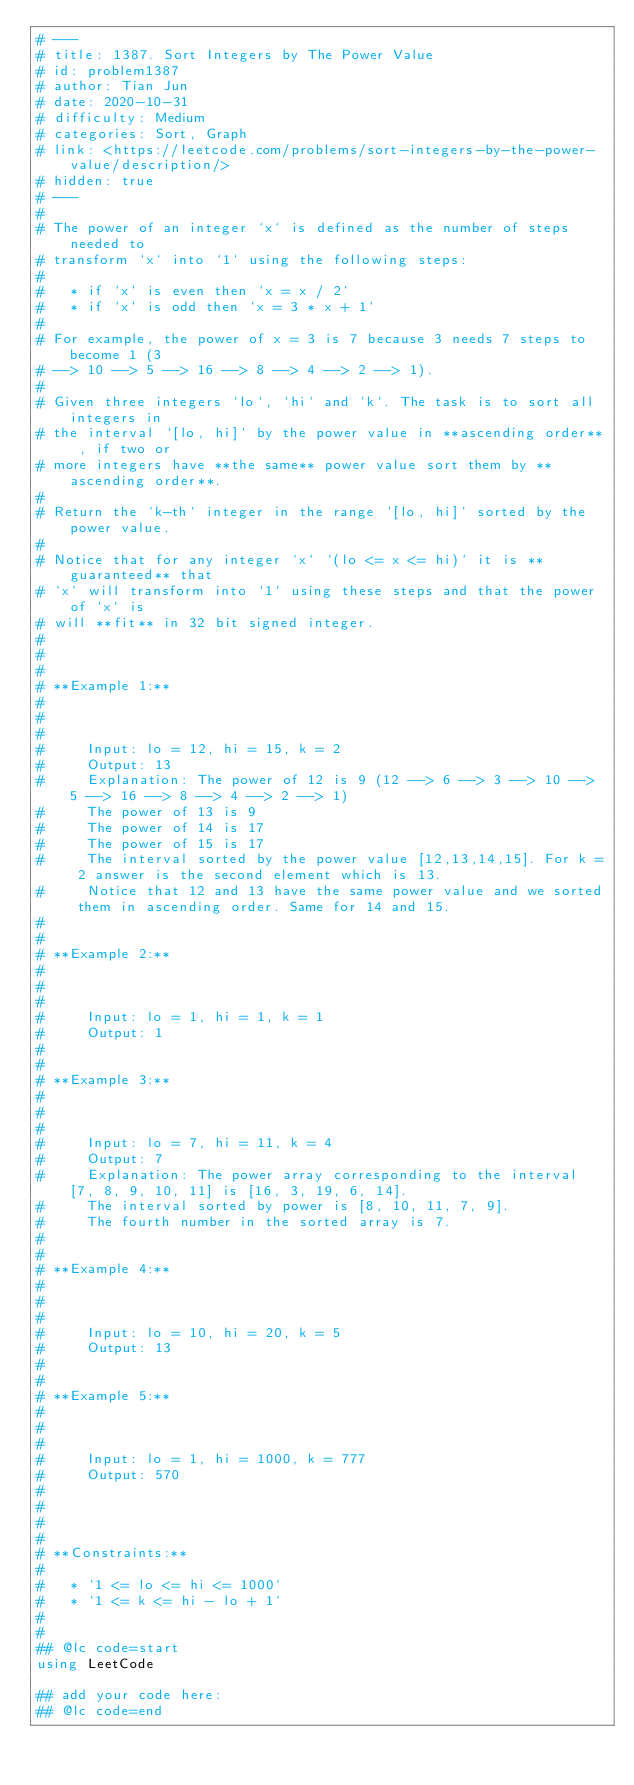Convert code to text. <code><loc_0><loc_0><loc_500><loc_500><_Julia_># ---
# title: 1387. Sort Integers by The Power Value
# id: problem1387
# author: Tian Jun
# date: 2020-10-31
# difficulty: Medium
# categories: Sort, Graph
# link: <https://leetcode.com/problems/sort-integers-by-the-power-value/description/>
# hidden: true
# ---
# 
# The power of an integer `x` is defined as the number of steps needed to
# transform `x` into `1` using the following steps:
# 
#   * if `x` is even then `x = x / 2`
#   * if `x` is odd then `x = 3 * x + 1`
# 
# For example, the power of x = 3 is 7 because 3 needs 7 steps to become 1 (3
# --> 10 --> 5 --> 16 --> 8 --> 4 --> 2 --> 1).
# 
# Given three integers `lo`, `hi` and `k`. The task is to sort all integers in
# the interval `[lo, hi]` by the power value in **ascending order** , if two or
# more integers have **the same** power value sort them by **ascending order**.
# 
# Return the `k-th` integer in the range `[lo, hi]` sorted by the power value.
# 
# Notice that for any integer `x` `(lo <= x <= hi)` it is **guaranteed** that
# `x` will transform into `1` using these steps and that the power of `x` is
# will **fit** in 32 bit signed integer.
# 
# 
# 
# **Example 1:**
# 
#     
#     
#     Input: lo = 12, hi = 15, k = 2
#     Output: 13
#     Explanation: The power of 12 is 9 (12 --> 6 --> 3 --> 10 --> 5 --> 16 --> 8 --> 4 --> 2 --> 1)
#     The power of 13 is 9
#     The power of 14 is 17
#     The power of 15 is 17
#     The interval sorted by the power value [12,13,14,15]. For k = 2 answer is the second element which is 13.
#     Notice that 12 and 13 have the same power value and we sorted them in ascending order. Same for 14 and 15.
#     
# 
# **Example 2:**
# 
#     
#     
#     Input: lo = 1, hi = 1, k = 1
#     Output: 1
#     
# 
# **Example 3:**
# 
#     
#     
#     Input: lo = 7, hi = 11, k = 4
#     Output: 7
#     Explanation: The power array corresponding to the interval [7, 8, 9, 10, 11] is [16, 3, 19, 6, 14].
#     The interval sorted by power is [8, 10, 11, 7, 9].
#     The fourth number in the sorted array is 7.
#     
# 
# **Example 4:**
# 
#     
#     
#     Input: lo = 10, hi = 20, k = 5
#     Output: 13
#     
# 
# **Example 5:**
# 
#     
#     
#     Input: lo = 1, hi = 1000, k = 777
#     Output: 570
#     
# 
# 
# 
# **Constraints:**
# 
#   * `1 <= lo <= hi <= 1000`
#   * `1 <= k <= hi - lo + 1`
# 
# 
## @lc code=start
using LeetCode

## add your code here:
## @lc code=end
</code> 